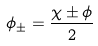Convert formula to latex. <formula><loc_0><loc_0><loc_500><loc_500>\phi _ { \pm } = \frac { \chi \pm \phi } { 2 }</formula> 